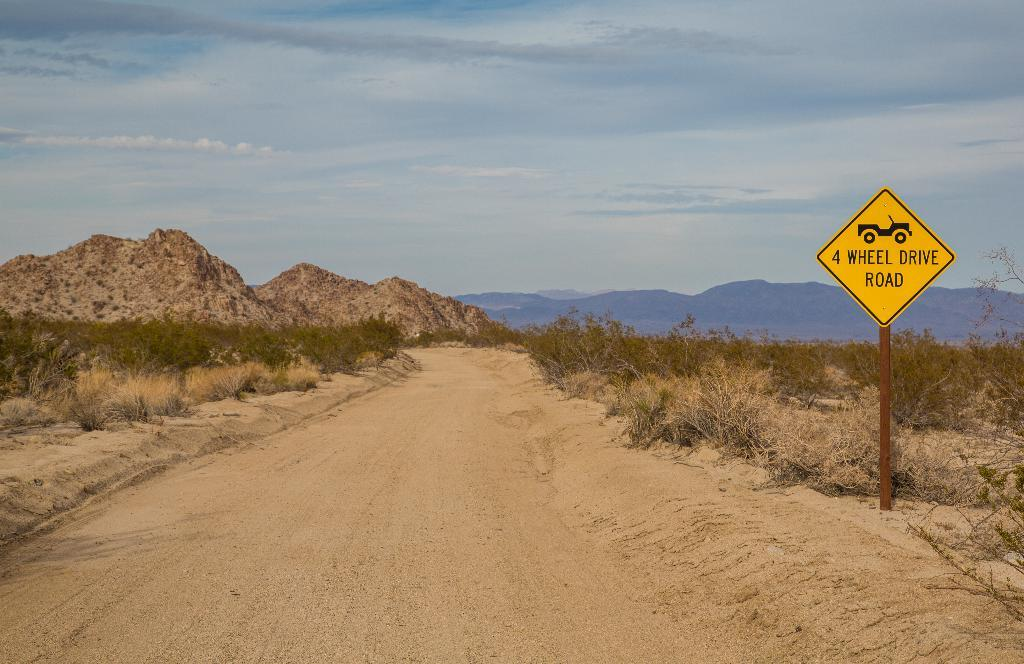Provide a one-sentence caption for the provided image. A dirt road has a yellow sign next to it that says 4 Wheel Drive Road. 